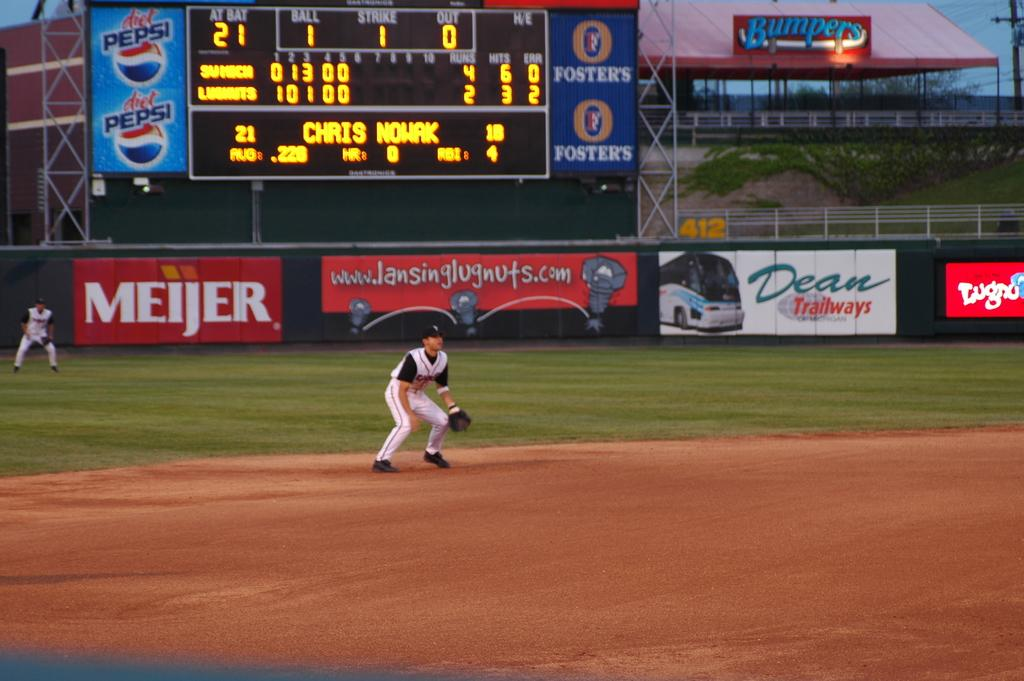Provide a one-sentence caption for the provided image. An ad for diet Pepsi appears to the left of the digital scoreboard. 